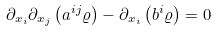<formula> <loc_0><loc_0><loc_500><loc_500>\partial _ { x _ { i } } \partial _ { x _ { j } } \left ( a ^ { i j } \varrho \right ) - \partial _ { x _ { i } } \left ( b ^ { i } \varrho \right ) = 0</formula> 